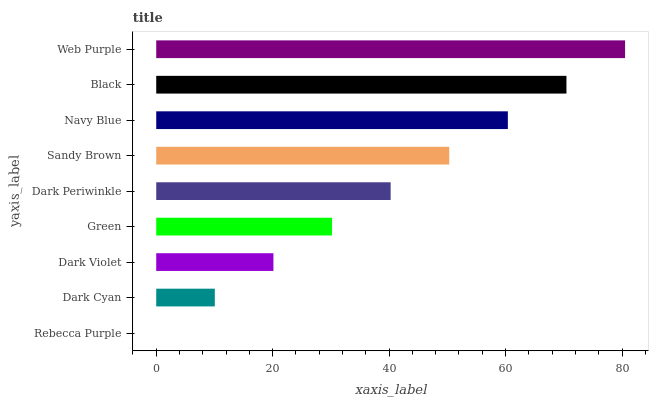Is Rebecca Purple the minimum?
Answer yes or no. Yes. Is Web Purple the maximum?
Answer yes or no. Yes. Is Dark Cyan the minimum?
Answer yes or no. No. Is Dark Cyan the maximum?
Answer yes or no. No. Is Dark Cyan greater than Rebecca Purple?
Answer yes or no. Yes. Is Rebecca Purple less than Dark Cyan?
Answer yes or no. Yes. Is Rebecca Purple greater than Dark Cyan?
Answer yes or no. No. Is Dark Cyan less than Rebecca Purple?
Answer yes or no. No. Is Dark Periwinkle the high median?
Answer yes or no. Yes. Is Dark Periwinkle the low median?
Answer yes or no. Yes. Is Black the high median?
Answer yes or no. No. Is Dark Cyan the low median?
Answer yes or no. No. 